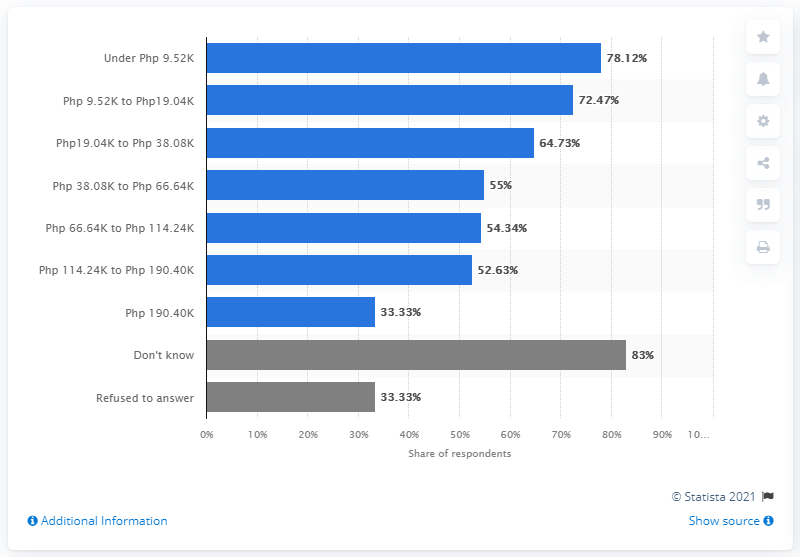Point out several critical features in this image. According to the latest data, 33.33% of households in the affected areas that had a member earning below PHP 9,500 lost their primary breadwinner due to the enhanced community quarantine. 